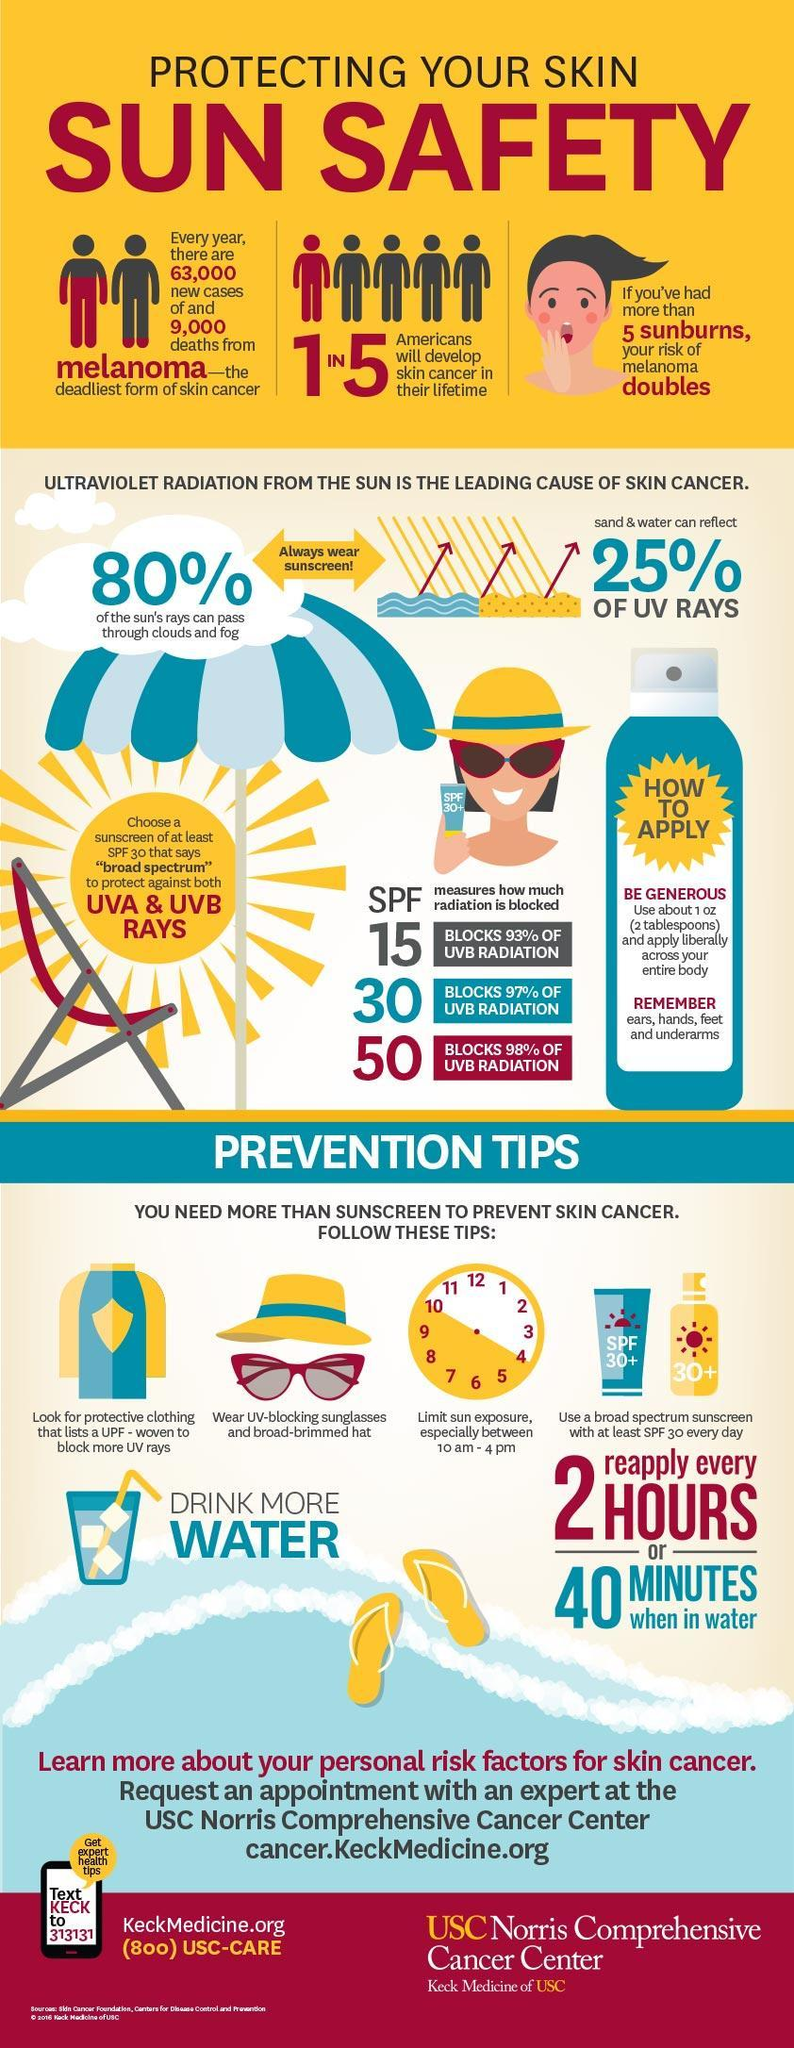What percentage of UV rays cannot pass through clouds and fog?
Answer the question with a short phrase. 20% What percentage of UV rays cannot be reflected by sand and water? 75% How many prevention tips are mentioned to avoid skin cancer? 5 